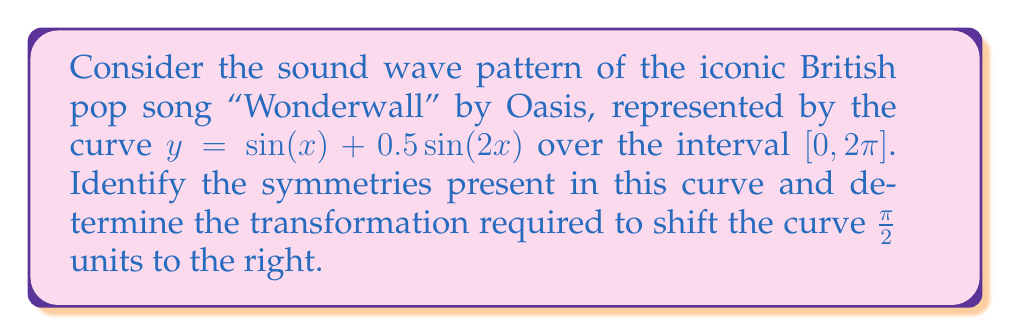Help me with this question. 1. First, let's analyze the symmetries of the curve $y = \sin(x) + 0.5\sin(2x)$:

   a) Even/Odd symmetry: 
      The function is neither even nor odd, as it's a sum of an odd function $\sin(x)$ and an even function $0.5\sin(2x)$.

   b) Period: 
      The period of $\sin(x)$ is $2\pi$, and the period of $\sin(2x)$ is $\pi$. 
      The least common multiple is $2\pi$, so the overall function has a period of $2\pi$.

   c) Half-turn symmetry: 
      The function has half-turn symmetry about the point $(\pi, 0)$, as:
      $f(x + \pi) = \sin(x + \pi) + 0.5\sin(2(x + \pi)) = -\sin(x) - 0.5\sin(2x) = -f(x)$

2. To shift the curve $\frac{\pi}{2}$ units to the right, we need to apply a horizontal translation:

   $y = \sin(x - \frac{\pi}{2}) + 0.5\sin(2(x - \frac{\pi}{2}))$

   This can be simplified using trigonometric identities:
   
   $y = -\cos(x) + 0.5\sin(2x - \pi) = -\cos(x) - 0.5\sin(2x)$

3. The transformation can be described as a composition of:
   - A horizontal translation of $\frac{\pi}{2}$ units to the right
   - A reflection over the x-axis for the $\sin(2x)$ term

Therefore, the required transformation is $T(x, y) = (x + \frac{\pi}{2}, -y)$ applied to the original function.
Answer: $T(x, y) = (x + \frac{\pi}{2}, -y)$ 